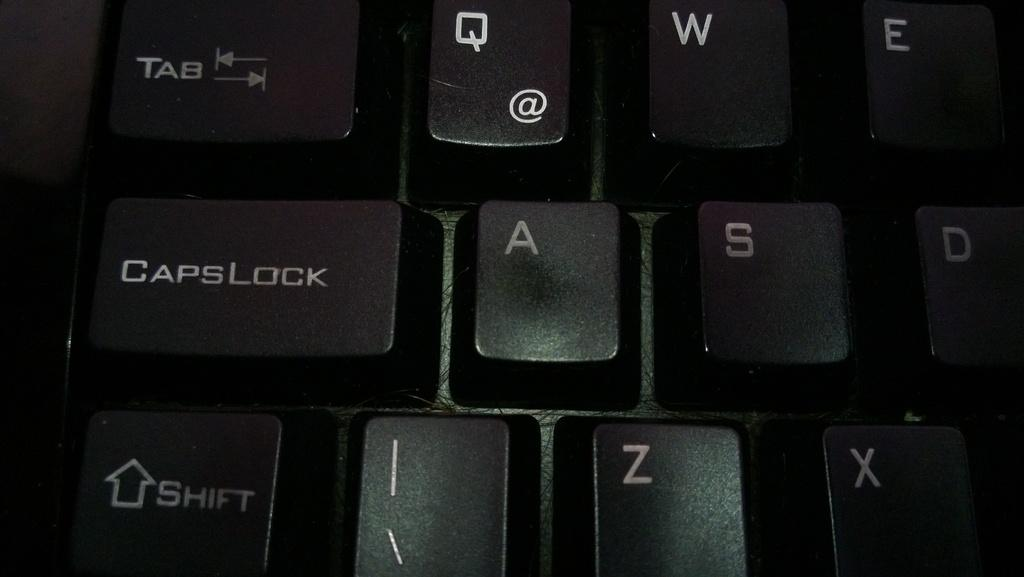<image>
Offer a succinct explanation of the picture presented. close up of a black keyboard and keys Caps LOCK and SHIFT 